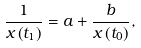<formula> <loc_0><loc_0><loc_500><loc_500>\frac { 1 } { x \left ( t _ { 1 } \right ) } = a + \frac { b } { x \left ( t _ { 0 } \right ) } ,</formula> 